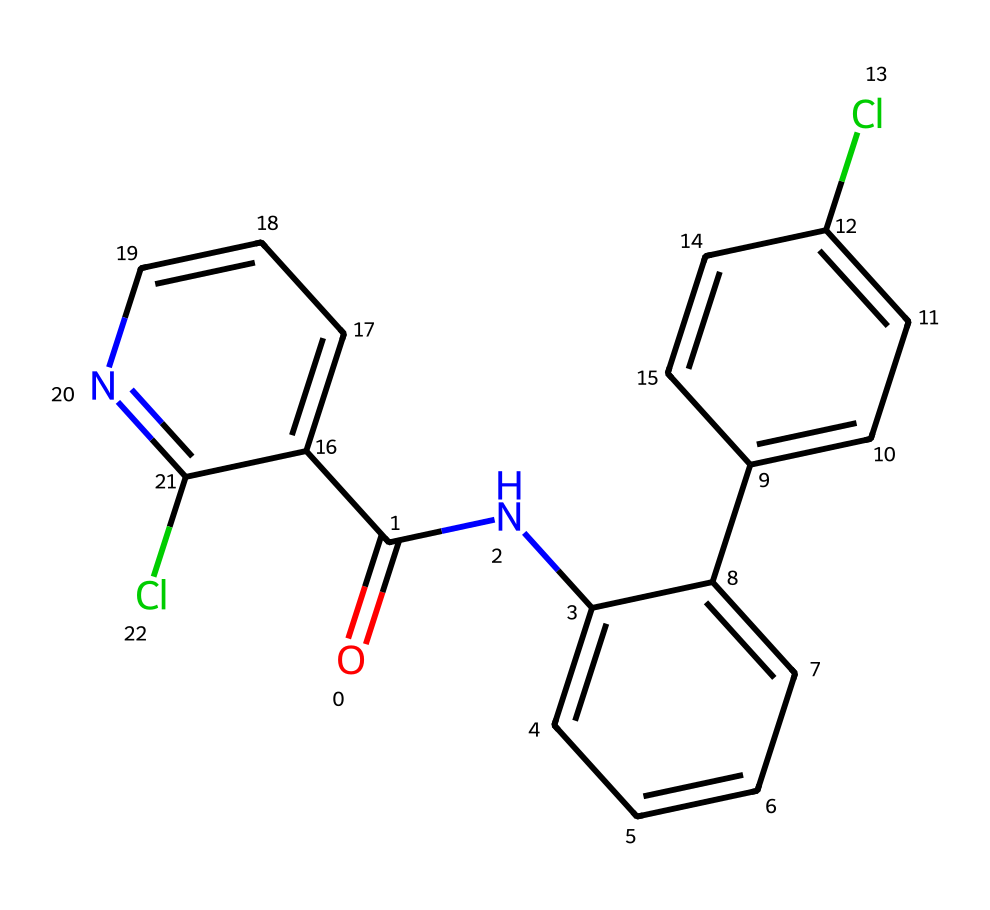What is the total number of carbon atoms in boscalid? By counting the carbon atoms in the chemical structure, there are 14 carbon atoms represented in the SMILES notation.
Answer: 14 How many chlorine atoms are present in this molecule? The SMILES shows two chlorine (Cl) atoms attached to the phenyl rings, confirming there are 2 chlorine atoms in the structure.
Answer: 2 What functional group is present in boscalid? The molecule contains an amide functional group, as indicated by the presence of the carbon double-bonded to oxygen (C=O) directly attached to a nitrogen atom (N).
Answer: amide Which part of boscalid contributes to its fungicidal activity? The presence of a nitrogen-containing heterocyclic ring and the amide functional group typically enhance the biological activity against fungi, indicating these features contribute to its fungicidal properties.
Answer: nitrogen heterocycle and amide What is the molecular formula derived from the structure of boscalid? From analyzing the SMILES representation, the molecular formula can be determined to be C14H12Cl2N2O.
Answer: C14H12Cl2N2O Is boscalid likely to be more hydrophilic or hydrophobic? Given the molecular structure with multiple aromatic rings and halogen substitutions (chlorine), it suggests that boscalid is more hydrophobic than hydrophilic due to the presence of non-polar carbon rings.
Answer: hydrophobic 